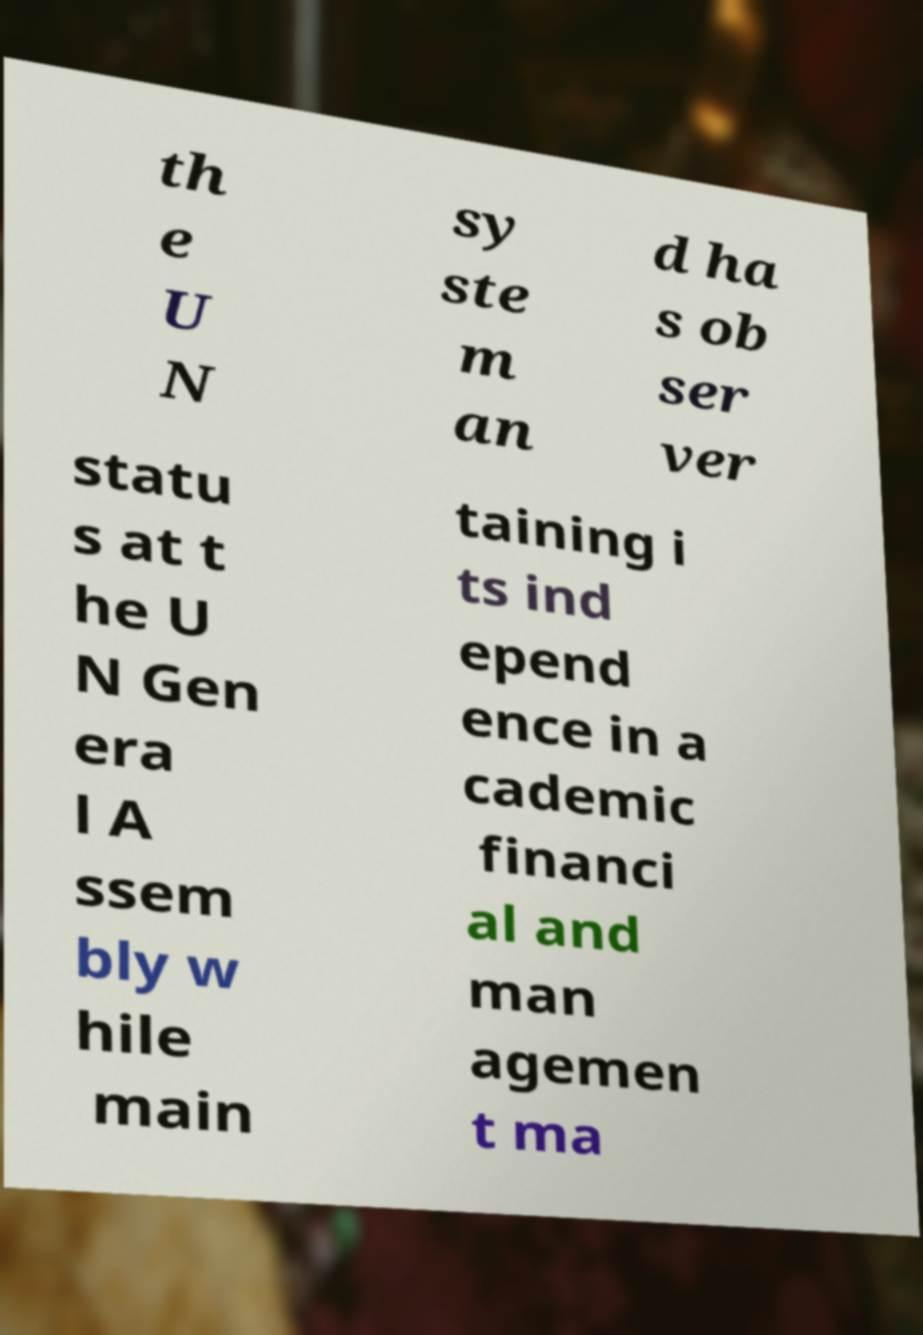Could you extract and type out the text from this image? th e U N sy ste m an d ha s ob ser ver statu s at t he U N Gen era l A ssem bly w hile main taining i ts ind epend ence in a cademic financi al and man agemen t ma 